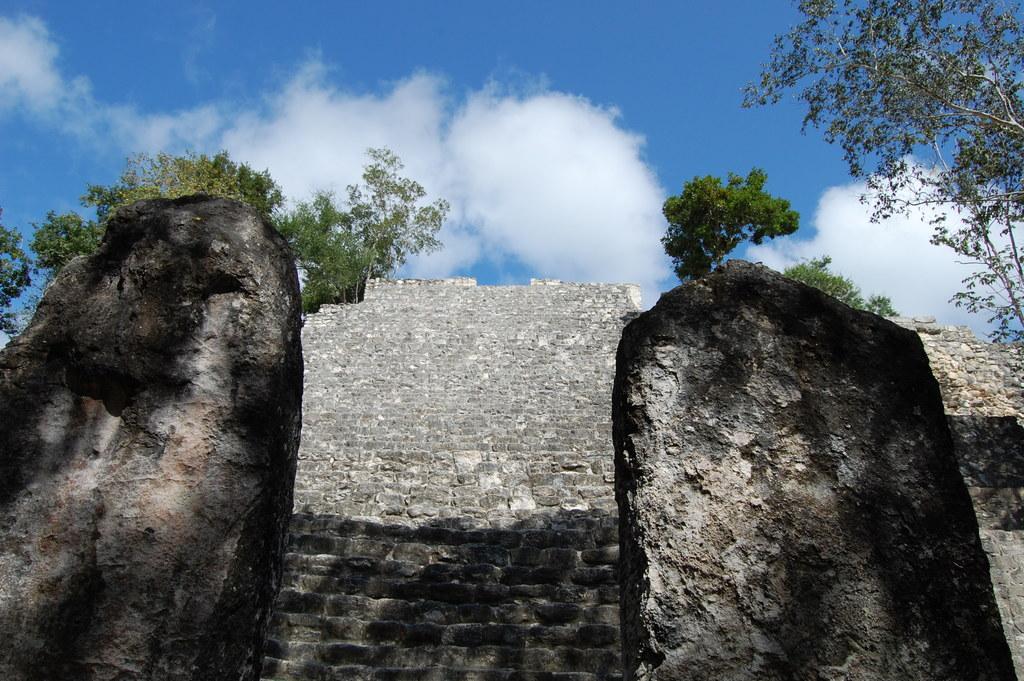Describe this image in one or two sentences. In this image I can see few stairs, and I can also see few rocks. Background I can see trees in green color and the sky is in blue and white color. 